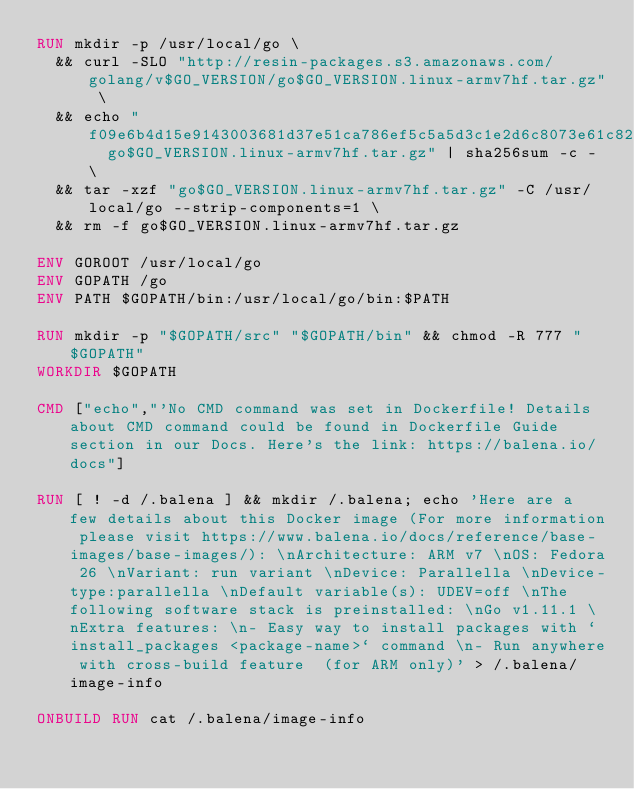<code> <loc_0><loc_0><loc_500><loc_500><_Dockerfile_>RUN mkdir -p /usr/local/go \
	&& curl -SLO "http://resin-packages.s3.amazonaws.com/golang/v$GO_VERSION/go$GO_VERSION.linux-armv7hf.tar.gz" \
	&& echo "f09e6b4d15e9143003681d37e51ca786ef5c5a5d3c1e2d6c8073e61c823b8c1a  go$GO_VERSION.linux-armv7hf.tar.gz" | sha256sum -c - \
	&& tar -xzf "go$GO_VERSION.linux-armv7hf.tar.gz" -C /usr/local/go --strip-components=1 \
	&& rm -f go$GO_VERSION.linux-armv7hf.tar.gz

ENV GOROOT /usr/local/go
ENV GOPATH /go
ENV PATH $GOPATH/bin:/usr/local/go/bin:$PATH

RUN mkdir -p "$GOPATH/src" "$GOPATH/bin" && chmod -R 777 "$GOPATH"
WORKDIR $GOPATH

CMD ["echo","'No CMD command was set in Dockerfile! Details about CMD command could be found in Dockerfile Guide section in our Docs. Here's the link: https://balena.io/docs"]

RUN [ ! -d /.balena ] && mkdir /.balena; echo 'Here are a few details about this Docker image (For more information please visit https://www.balena.io/docs/reference/base-images/base-images/): \nArchitecture: ARM v7 \nOS: Fedora 26 \nVariant: run variant \nDevice: Parallella \nDevice-type:parallella \nDefault variable(s): UDEV=off \nThe following software stack is preinstalled: \nGo v1.11.1 \nExtra features: \n- Easy way to install packages with `install_packages <package-name>` command \n- Run anywhere with cross-build feature  (for ARM only)' > /.balena/image-info

ONBUILD RUN cat /.balena/image-info</code> 